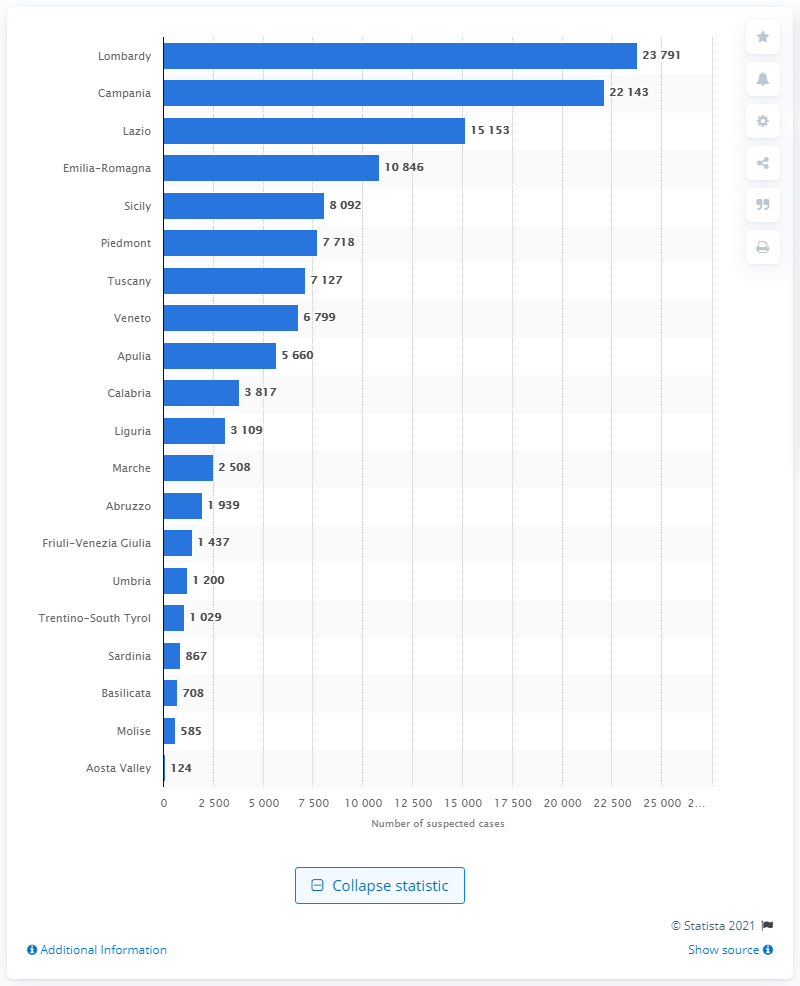Which region in Italy had the second highest number of suspected financial operations in 2019? Campania is the region with the second-highest number of suspected financial operations in 2019, recording 22,143 cases. 